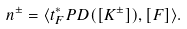<formula> <loc_0><loc_0><loc_500><loc_500>n ^ { \pm } = \langle t _ { F } ^ { * } P D ( [ K ^ { \pm } ] ) , [ F ] \rangle .</formula> 